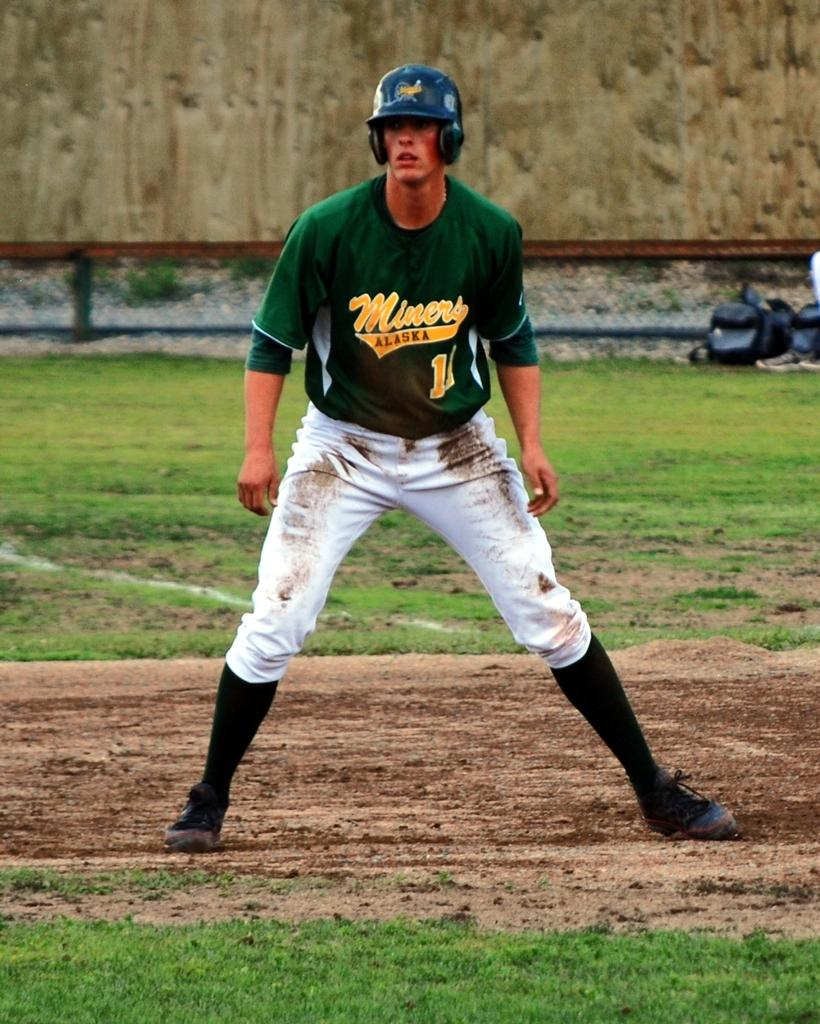<image>
Summarize the visual content of the image. An Alaska Miners player takes his lead from first base. 